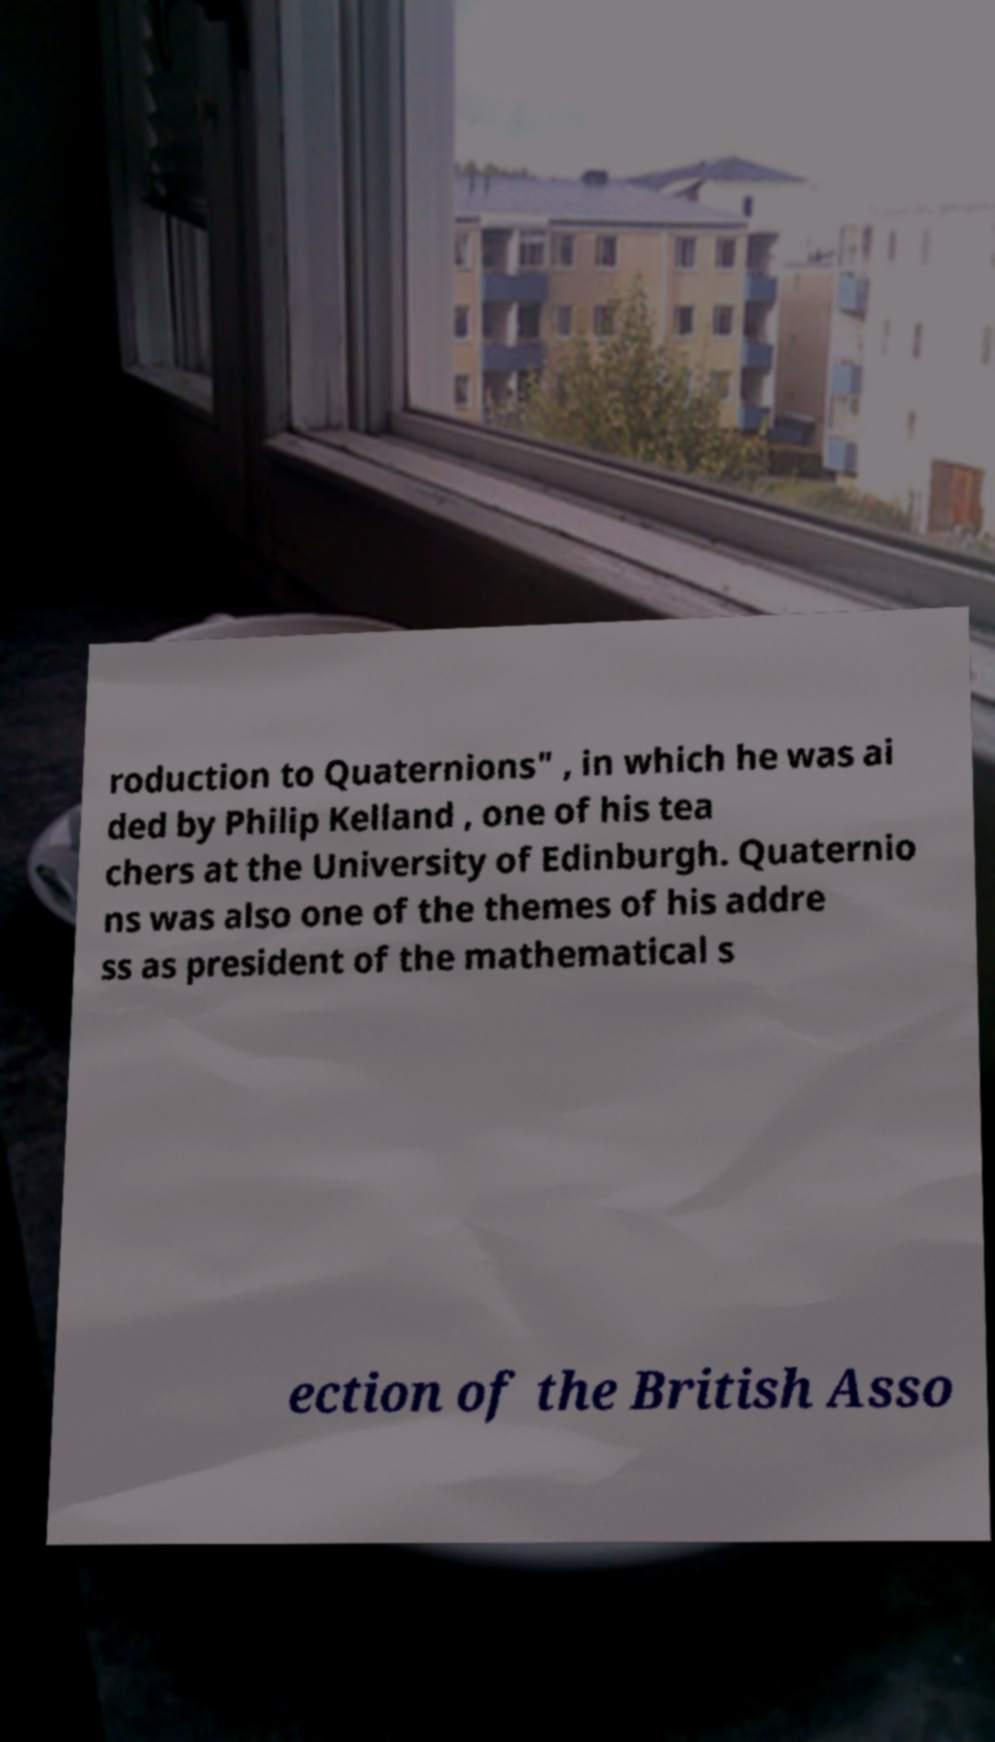For documentation purposes, I need the text within this image transcribed. Could you provide that? roduction to Quaternions" , in which he was ai ded by Philip Kelland , one of his tea chers at the University of Edinburgh. Quaternio ns was also one of the themes of his addre ss as president of the mathematical s ection of the British Asso 